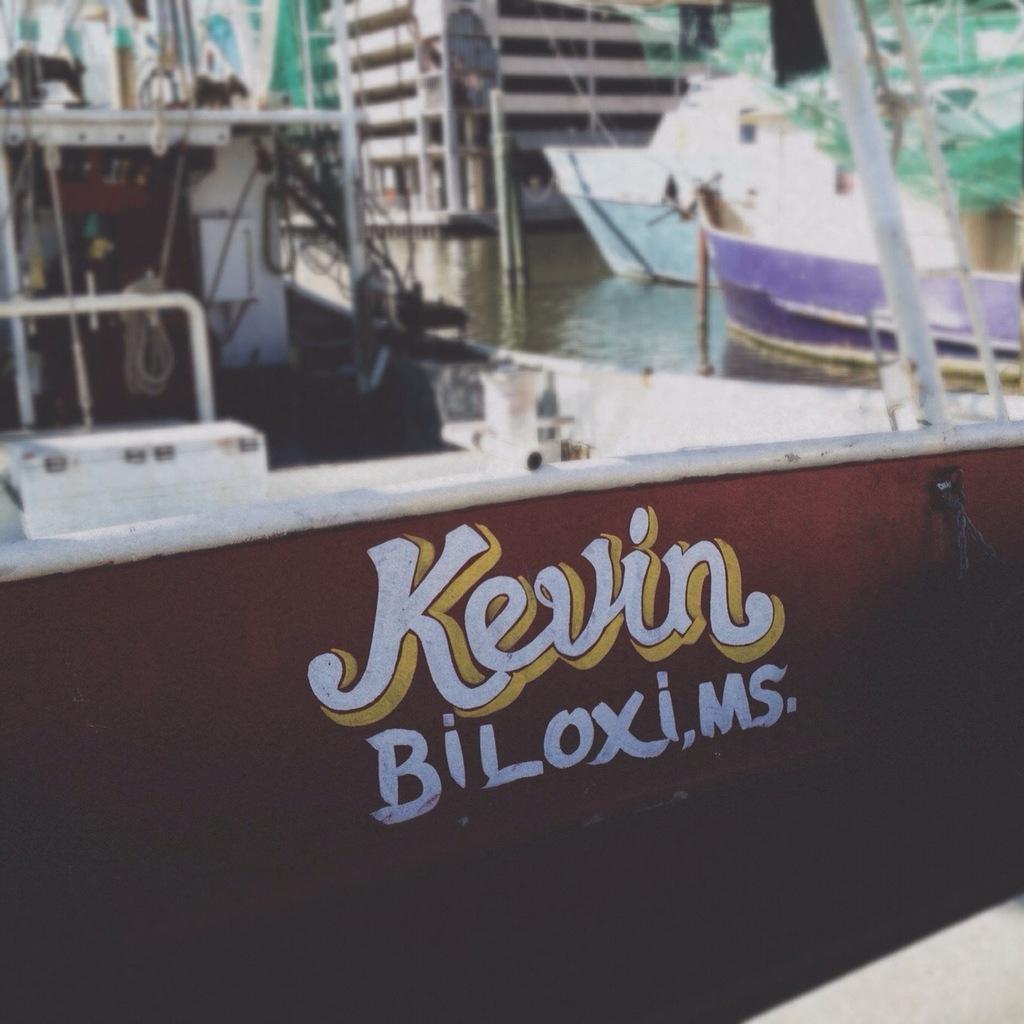Please provide a concise description of this image. There is a painting of the texts on the brown color surface. In the background, there are boats on the water and there is a building. 